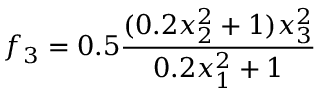Convert formula to latex. <formula><loc_0><loc_0><loc_500><loc_500>f _ { 3 } = 0 . 5 \frac { ( 0 . 2 x _ { 2 } ^ { 2 } + 1 ) x _ { 3 } ^ { 2 } } { 0 . 2 x _ { 1 } ^ { 2 } + 1 }</formula> 